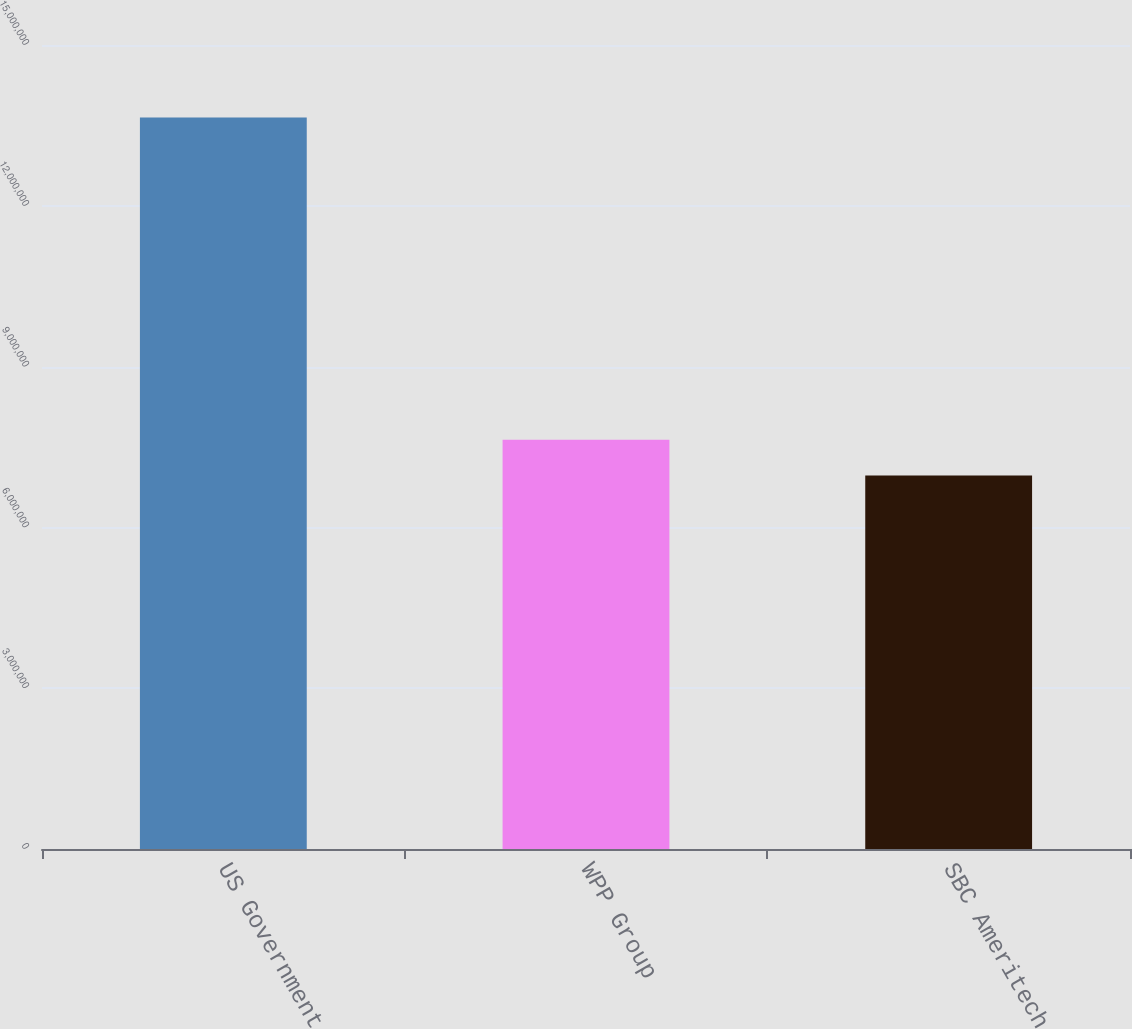Convert chart. <chart><loc_0><loc_0><loc_500><loc_500><bar_chart><fcel>US Government<fcel>WPP Group<fcel>SBC Ameritech<nl><fcel>1.3647e+07<fcel>7.6359e+06<fcel>6.968e+06<nl></chart> 